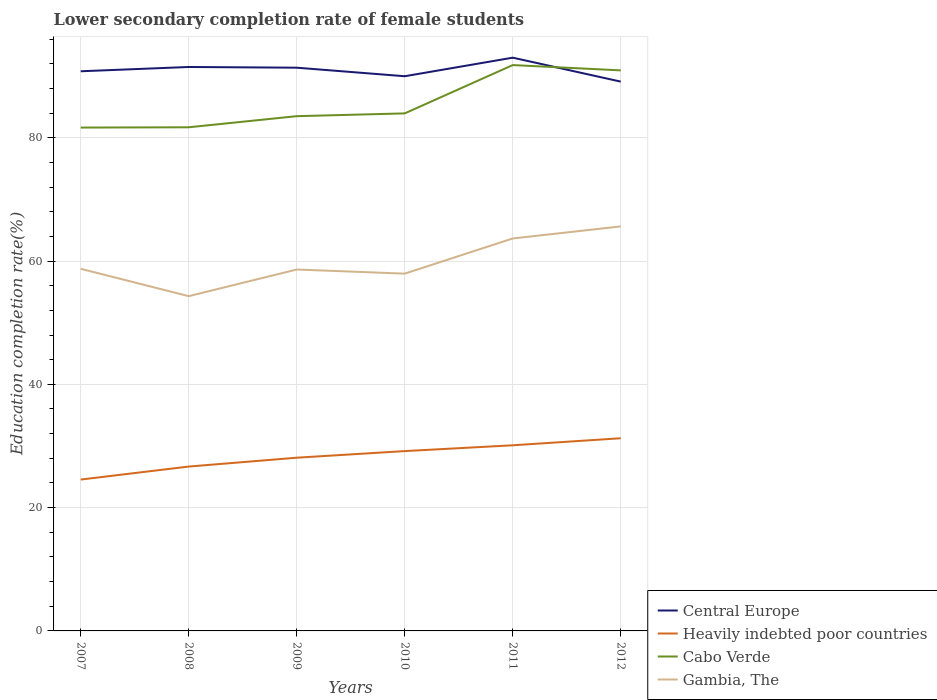How many different coloured lines are there?
Offer a terse response. 4. Across all years, what is the maximum lower secondary completion rate of female students in Gambia, The?
Make the answer very short. 54.3. In which year was the lower secondary completion rate of female students in Central Europe maximum?
Provide a succinct answer. 2012. What is the total lower secondary completion rate of female students in Cabo Verde in the graph?
Your answer should be very brief. 0.86. What is the difference between the highest and the second highest lower secondary completion rate of female students in Gambia, The?
Offer a very short reply. 11.31. What is the difference between the highest and the lowest lower secondary completion rate of female students in Cabo Verde?
Offer a terse response. 2. Are the values on the major ticks of Y-axis written in scientific E-notation?
Ensure brevity in your answer.  No. Does the graph contain any zero values?
Keep it short and to the point. No. How are the legend labels stacked?
Provide a short and direct response. Vertical. What is the title of the graph?
Offer a very short reply. Lower secondary completion rate of female students. What is the label or title of the Y-axis?
Make the answer very short. Education completion rate(%). What is the Education completion rate(%) in Central Europe in 2007?
Your answer should be very brief. 90.78. What is the Education completion rate(%) in Heavily indebted poor countries in 2007?
Keep it short and to the point. 24.55. What is the Education completion rate(%) in Cabo Verde in 2007?
Ensure brevity in your answer.  81.65. What is the Education completion rate(%) in Gambia, The in 2007?
Offer a very short reply. 58.74. What is the Education completion rate(%) of Central Europe in 2008?
Your answer should be compact. 91.48. What is the Education completion rate(%) of Heavily indebted poor countries in 2008?
Make the answer very short. 26.66. What is the Education completion rate(%) in Cabo Verde in 2008?
Offer a very short reply. 81.7. What is the Education completion rate(%) of Gambia, The in 2008?
Your response must be concise. 54.3. What is the Education completion rate(%) in Central Europe in 2009?
Keep it short and to the point. 91.36. What is the Education completion rate(%) in Heavily indebted poor countries in 2009?
Provide a succinct answer. 28.1. What is the Education completion rate(%) in Cabo Verde in 2009?
Provide a short and direct response. 83.5. What is the Education completion rate(%) of Gambia, The in 2009?
Your answer should be compact. 58.62. What is the Education completion rate(%) in Central Europe in 2010?
Offer a very short reply. 89.98. What is the Education completion rate(%) in Heavily indebted poor countries in 2010?
Ensure brevity in your answer.  29.17. What is the Education completion rate(%) in Cabo Verde in 2010?
Your answer should be very brief. 83.95. What is the Education completion rate(%) in Gambia, The in 2010?
Your answer should be very brief. 57.96. What is the Education completion rate(%) of Central Europe in 2011?
Keep it short and to the point. 92.99. What is the Education completion rate(%) in Heavily indebted poor countries in 2011?
Keep it short and to the point. 30.11. What is the Education completion rate(%) of Cabo Verde in 2011?
Your answer should be very brief. 91.79. What is the Education completion rate(%) of Gambia, The in 2011?
Make the answer very short. 63.66. What is the Education completion rate(%) in Central Europe in 2012?
Make the answer very short. 89.1. What is the Education completion rate(%) of Heavily indebted poor countries in 2012?
Ensure brevity in your answer.  31.25. What is the Education completion rate(%) in Cabo Verde in 2012?
Make the answer very short. 90.93. What is the Education completion rate(%) in Gambia, The in 2012?
Offer a very short reply. 65.62. Across all years, what is the maximum Education completion rate(%) in Central Europe?
Provide a short and direct response. 92.99. Across all years, what is the maximum Education completion rate(%) in Heavily indebted poor countries?
Keep it short and to the point. 31.25. Across all years, what is the maximum Education completion rate(%) of Cabo Verde?
Provide a succinct answer. 91.79. Across all years, what is the maximum Education completion rate(%) in Gambia, The?
Make the answer very short. 65.62. Across all years, what is the minimum Education completion rate(%) of Central Europe?
Provide a short and direct response. 89.1. Across all years, what is the minimum Education completion rate(%) of Heavily indebted poor countries?
Give a very brief answer. 24.55. Across all years, what is the minimum Education completion rate(%) of Cabo Verde?
Offer a very short reply. 81.65. Across all years, what is the minimum Education completion rate(%) in Gambia, The?
Your answer should be very brief. 54.3. What is the total Education completion rate(%) in Central Europe in the graph?
Provide a succinct answer. 545.69. What is the total Education completion rate(%) of Heavily indebted poor countries in the graph?
Keep it short and to the point. 169.85. What is the total Education completion rate(%) in Cabo Verde in the graph?
Provide a succinct answer. 513.51. What is the total Education completion rate(%) of Gambia, The in the graph?
Provide a succinct answer. 358.91. What is the difference between the Education completion rate(%) in Central Europe in 2007 and that in 2008?
Keep it short and to the point. -0.69. What is the difference between the Education completion rate(%) of Heavily indebted poor countries in 2007 and that in 2008?
Provide a succinct answer. -2.11. What is the difference between the Education completion rate(%) of Cabo Verde in 2007 and that in 2008?
Ensure brevity in your answer.  -0.05. What is the difference between the Education completion rate(%) in Gambia, The in 2007 and that in 2008?
Keep it short and to the point. 4.44. What is the difference between the Education completion rate(%) of Central Europe in 2007 and that in 2009?
Keep it short and to the point. -0.58. What is the difference between the Education completion rate(%) of Heavily indebted poor countries in 2007 and that in 2009?
Make the answer very short. -3.54. What is the difference between the Education completion rate(%) in Cabo Verde in 2007 and that in 2009?
Give a very brief answer. -1.85. What is the difference between the Education completion rate(%) in Gambia, The in 2007 and that in 2009?
Your answer should be compact. 0.12. What is the difference between the Education completion rate(%) in Central Europe in 2007 and that in 2010?
Keep it short and to the point. 0.81. What is the difference between the Education completion rate(%) in Heavily indebted poor countries in 2007 and that in 2010?
Offer a very short reply. -4.62. What is the difference between the Education completion rate(%) in Cabo Verde in 2007 and that in 2010?
Your response must be concise. -2.3. What is the difference between the Education completion rate(%) in Gambia, The in 2007 and that in 2010?
Your answer should be very brief. 0.79. What is the difference between the Education completion rate(%) of Central Europe in 2007 and that in 2011?
Your answer should be very brief. -2.21. What is the difference between the Education completion rate(%) in Heavily indebted poor countries in 2007 and that in 2011?
Your answer should be very brief. -5.56. What is the difference between the Education completion rate(%) in Cabo Verde in 2007 and that in 2011?
Keep it short and to the point. -10.14. What is the difference between the Education completion rate(%) in Gambia, The in 2007 and that in 2011?
Provide a succinct answer. -4.92. What is the difference between the Education completion rate(%) in Central Europe in 2007 and that in 2012?
Make the answer very short. 1.68. What is the difference between the Education completion rate(%) of Heavily indebted poor countries in 2007 and that in 2012?
Your answer should be very brief. -6.7. What is the difference between the Education completion rate(%) in Cabo Verde in 2007 and that in 2012?
Offer a very short reply. -9.28. What is the difference between the Education completion rate(%) of Gambia, The in 2007 and that in 2012?
Ensure brevity in your answer.  -6.87. What is the difference between the Education completion rate(%) of Central Europe in 2008 and that in 2009?
Ensure brevity in your answer.  0.11. What is the difference between the Education completion rate(%) of Heavily indebted poor countries in 2008 and that in 2009?
Provide a succinct answer. -1.44. What is the difference between the Education completion rate(%) of Cabo Verde in 2008 and that in 2009?
Your answer should be compact. -1.8. What is the difference between the Education completion rate(%) in Gambia, The in 2008 and that in 2009?
Your response must be concise. -4.32. What is the difference between the Education completion rate(%) in Central Europe in 2008 and that in 2010?
Provide a succinct answer. 1.5. What is the difference between the Education completion rate(%) in Heavily indebted poor countries in 2008 and that in 2010?
Your answer should be compact. -2.51. What is the difference between the Education completion rate(%) in Cabo Verde in 2008 and that in 2010?
Provide a short and direct response. -2.25. What is the difference between the Education completion rate(%) of Gambia, The in 2008 and that in 2010?
Your response must be concise. -3.65. What is the difference between the Education completion rate(%) in Central Europe in 2008 and that in 2011?
Keep it short and to the point. -1.51. What is the difference between the Education completion rate(%) in Heavily indebted poor countries in 2008 and that in 2011?
Make the answer very short. -3.45. What is the difference between the Education completion rate(%) of Cabo Verde in 2008 and that in 2011?
Offer a terse response. -10.09. What is the difference between the Education completion rate(%) of Gambia, The in 2008 and that in 2011?
Offer a very short reply. -9.36. What is the difference between the Education completion rate(%) in Central Europe in 2008 and that in 2012?
Ensure brevity in your answer.  2.37. What is the difference between the Education completion rate(%) of Heavily indebted poor countries in 2008 and that in 2012?
Make the answer very short. -4.59. What is the difference between the Education completion rate(%) of Cabo Verde in 2008 and that in 2012?
Your answer should be very brief. -9.23. What is the difference between the Education completion rate(%) in Gambia, The in 2008 and that in 2012?
Offer a very short reply. -11.31. What is the difference between the Education completion rate(%) in Central Europe in 2009 and that in 2010?
Your response must be concise. 1.39. What is the difference between the Education completion rate(%) in Heavily indebted poor countries in 2009 and that in 2010?
Your answer should be very brief. -1.07. What is the difference between the Education completion rate(%) of Cabo Verde in 2009 and that in 2010?
Make the answer very short. -0.45. What is the difference between the Education completion rate(%) of Gambia, The in 2009 and that in 2010?
Your answer should be compact. 0.67. What is the difference between the Education completion rate(%) in Central Europe in 2009 and that in 2011?
Offer a very short reply. -1.63. What is the difference between the Education completion rate(%) in Heavily indebted poor countries in 2009 and that in 2011?
Ensure brevity in your answer.  -2.02. What is the difference between the Education completion rate(%) of Cabo Verde in 2009 and that in 2011?
Your response must be concise. -8.29. What is the difference between the Education completion rate(%) of Gambia, The in 2009 and that in 2011?
Your answer should be compact. -5.04. What is the difference between the Education completion rate(%) in Central Europe in 2009 and that in 2012?
Make the answer very short. 2.26. What is the difference between the Education completion rate(%) of Heavily indebted poor countries in 2009 and that in 2012?
Provide a succinct answer. -3.16. What is the difference between the Education completion rate(%) of Cabo Verde in 2009 and that in 2012?
Keep it short and to the point. -7.43. What is the difference between the Education completion rate(%) of Gambia, The in 2009 and that in 2012?
Make the answer very short. -6.99. What is the difference between the Education completion rate(%) in Central Europe in 2010 and that in 2011?
Offer a terse response. -3.01. What is the difference between the Education completion rate(%) of Heavily indebted poor countries in 2010 and that in 2011?
Keep it short and to the point. -0.94. What is the difference between the Education completion rate(%) in Cabo Verde in 2010 and that in 2011?
Offer a terse response. -7.84. What is the difference between the Education completion rate(%) of Gambia, The in 2010 and that in 2011?
Offer a very short reply. -5.71. What is the difference between the Education completion rate(%) of Central Europe in 2010 and that in 2012?
Make the answer very short. 0.87. What is the difference between the Education completion rate(%) of Heavily indebted poor countries in 2010 and that in 2012?
Make the answer very short. -2.08. What is the difference between the Education completion rate(%) in Cabo Verde in 2010 and that in 2012?
Keep it short and to the point. -6.98. What is the difference between the Education completion rate(%) in Gambia, The in 2010 and that in 2012?
Provide a short and direct response. -7.66. What is the difference between the Education completion rate(%) in Central Europe in 2011 and that in 2012?
Offer a terse response. 3.88. What is the difference between the Education completion rate(%) of Heavily indebted poor countries in 2011 and that in 2012?
Keep it short and to the point. -1.14. What is the difference between the Education completion rate(%) of Cabo Verde in 2011 and that in 2012?
Ensure brevity in your answer.  0.86. What is the difference between the Education completion rate(%) in Gambia, The in 2011 and that in 2012?
Your response must be concise. -1.95. What is the difference between the Education completion rate(%) in Central Europe in 2007 and the Education completion rate(%) in Heavily indebted poor countries in 2008?
Offer a very short reply. 64.12. What is the difference between the Education completion rate(%) of Central Europe in 2007 and the Education completion rate(%) of Cabo Verde in 2008?
Provide a short and direct response. 9.08. What is the difference between the Education completion rate(%) of Central Europe in 2007 and the Education completion rate(%) of Gambia, The in 2008?
Provide a short and direct response. 36.48. What is the difference between the Education completion rate(%) of Heavily indebted poor countries in 2007 and the Education completion rate(%) of Cabo Verde in 2008?
Your answer should be very brief. -57.14. What is the difference between the Education completion rate(%) of Heavily indebted poor countries in 2007 and the Education completion rate(%) of Gambia, The in 2008?
Provide a succinct answer. -29.75. What is the difference between the Education completion rate(%) in Cabo Verde in 2007 and the Education completion rate(%) in Gambia, The in 2008?
Ensure brevity in your answer.  27.35. What is the difference between the Education completion rate(%) of Central Europe in 2007 and the Education completion rate(%) of Heavily indebted poor countries in 2009?
Offer a terse response. 62.68. What is the difference between the Education completion rate(%) in Central Europe in 2007 and the Education completion rate(%) in Cabo Verde in 2009?
Give a very brief answer. 7.28. What is the difference between the Education completion rate(%) of Central Europe in 2007 and the Education completion rate(%) of Gambia, The in 2009?
Provide a short and direct response. 32.16. What is the difference between the Education completion rate(%) in Heavily indebted poor countries in 2007 and the Education completion rate(%) in Cabo Verde in 2009?
Provide a succinct answer. -58.94. What is the difference between the Education completion rate(%) in Heavily indebted poor countries in 2007 and the Education completion rate(%) in Gambia, The in 2009?
Provide a short and direct response. -34.07. What is the difference between the Education completion rate(%) of Cabo Verde in 2007 and the Education completion rate(%) of Gambia, The in 2009?
Provide a short and direct response. 23.02. What is the difference between the Education completion rate(%) of Central Europe in 2007 and the Education completion rate(%) of Heavily indebted poor countries in 2010?
Make the answer very short. 61.61. What is the difference between the Education completion rate(%) of Central Europe in 2007 and the Education completion rate(%) of Cabo Verde in 2010?
Offer a terse response. 6.83. What is the difference between the Education completion rate(%) in Central Europe in 2007 and the Education completion rate(%) in Gambia, The in 2010?
Offer a very short reply. 32.83. What is the difference between the Education completion rate(%) of Heavily indebted poor countries in 2007 and the Education completion rate(%) of Cabo Verde in 2010?
Your response must be concise. -59.4. What is the difference between the Education completion rate(%) in Heavily indebted poor countries in 2007 and the Education completion rate(%) in Gambia, The in 2010?
Give a very brief answer. -33.4. What is the difference between the Education completion rate(%) in Cabo Verde in 2007 and the Education completion rate(%) in Gambia, The in 2010?
Provide a succinct answer. 23.69. What is the difference between the Education completion rate(%) in Central Europe in 2007 and the Education completion rate(%) in Heavily indebted poor countries in 2011?
Ensure brevity in your answer.  60.67. What is the difference between the Education completion rate(%) in Central Europe in 2007 and the Education completion rate(%) in Cabo Verde in 2011?
Make the answer very short. -1. What is the difference between the Education completion rate(%) of Central Europe in 2007 and the Education completion rate(%) of Gambia, The in 2011?
Keep it short and to the point. 27.12. What is the difference between the Education completion rate(%) in Heavily indebted poor countries in 2007 and the Education completion rate(%) in Cabo Verde in 2011?
Your answer should be very brief. -67.23. What is the difference between the Education completion rate(%) of Heavily indebted poor countries in 2007 and the Education completion rate(%) of Gambia, The in 2011?
Offer a terse response. -39.11. What is the difference between the Education completion rate(%) of Cabo Verde in 2007 and the Education completion rate(%) of Gambia, The in 2011?
Your response must be concise. 17.99. What is the difference between the Education completion rate(%) of Central Europe in 2007 and the Education completion rate(%) of Heavily indebted poor countries in 2012?
Your answer should be compact. 59.53. What is the difference between the Education completion rate(%) in Central Europe in 2007 and the Education completion rate(%) in Cabo Verde in 2012?
Keep it short and to the point. -0.15. What is the difference between the Education completion rate(%) in Central Europe in 2007 and the Education completion rate(%) in Gambia, The in 2012?
Offer a very short reply. 25.16. What is the difference between the Education completion rate(%) in Heavily indebted poor countries in 2007 and the Education completion rate(%) in Cabo Verde in 2012?
Keep it short and to the point. -66.37. What is the difference between the Education completion rate(%) of Heavily indebted poor countries in 2007 and the Education completion rate(%) of Gambia, The in 2012?
Ensure brevity in your answer.  -41.06. What is the difference between the Education completion rate(%) of Cabo Verde in 2007 and the Education completion rate(%) of Gambia, The in 2012?
Your answer should be very brief. 16.03. What is the difference between the Education completion rate(%) in Central Europe in 2008 and the Education completion rate(%) in Heavily indebted poor countries in 2009?
Offer a very short reply. 63.38. What is the difference between the Education completion rate(%) of Central Europe in 2008 and the Education completion rate(%) of Cabo Verde in 2009?
Provide a short and direct response. 7.98. What is the difference between the Education completion rate(%) of Central Europe in 2008 and the Education completion rate(%) of Gambia, The in 2009?
Make the answer very short. 32.85. What is the difference between the Education completion rate(%) of Heavily indebted poor countries in 2008 and the Education completion rate(%) of Cabo Verde in 2009?
Your response must be concise. -56.84. What is the difference between the Education completion rate(%) in Heavily indebted poor countries in 2008 and the Education completion rate(%) in Gambia, The in 2009?
Your answer should be very brief. -31.96. What is the difference between the Education completion rate(%) in Cabo Verde in 2008 and the Education completion rate(%) in Gambia, The in 2009?
Your response must be concise. 23.07. What is the difference between the Education completion rate(%) of Central Europe in 2008 and the Education completion rate(%) of Heavily indebted poor countries in 2010?
Offer a terse response. 62.31. What is the difference between the Education completion rate(%) of Central Europe in 2008 and the Education completion rate(%) of Cabo Verde in 2010?
Make the answer very short. 7.53. What is the difference between the Education completion rate(%) of Central Europe in 2008 and the Education completion rate(%) of Gambia, The in 2010?
Your answer should be very brief. 33.52. What is the difference between the Education completion rate(%) in Heavily indebted poor countries in 2008 and the Education completion rate(%) in Cabo Verde in 2010?
Give a very brief answer. -57.29. What is the difference between the Education completion rate(%) in Heavily indebted poor countries in 2008 and the Education completion rate(%) in Gambia, The in 2010?
Offer a terse response. -31.29. What is the difference between the Education completion rate(%) of Cabo Verde in 2008 and the Education completion rate(%) of Gambia, The in 2010?
Keep it short and to the point. 23.74. What is the difference between the Education completion rate(%) of Central Europe in 2008 and the Education completion rate(%) of Heavily indebted poor countries in 2011?
Keep it short and to the point. 61.36. What is the difference between the Education completion rate(%) of Central Europe in 2008 and the Education completion rate(%) of Cabo Verde in 2011?
Offer a terse response. -0.31. What is the difference between the Education completion rate(%) of Central Europe in 2008 and the Education completion rate(%) of Gambia, The in 2011?
Offer a terse response. 27.81. What is the difference between the Education completion rate(%) in Heavily indebted poor countries in 2008 and the Education completion rate(%) in Cabo Verde in 2011?
Ensure brevity in your answer.  -65.12. What is the difference between the Education completion rate(%) of Heavily indebted poor countries in 2008 and the Education completion rate(%) of Gambia, The in 2011?
Provide a short and direct response. -37. What is the difference between the Education completion rate(%) of Cabo Verde in 2008 and the Education completion rate(%) of Gambia, The in 2011?
Provide a short and direct response. 18.04. What is the difference between the Education completion rate(%) of Central Europe in 2008 and the Education completion rate(%) of Heavily indebted poor countries in 2012?
Give a very brief answer. 60.22. What is the difference between the Education completion rate(%) of Central Europe in 2008 and the Education completion rate(%) of Cabo Verde in 2012?
Make the answer very short. 0.55. What is the difference between the Education completion rate(%) of Central Europe in 2008 and the Education completion rate(%) of Gambia, The in 2012?
Offer a very short reply. 25.86. What is the difference between the Education completion rate(%) of Heavily indebted poor countries in 2008 and the Education completion rate(%) of Cabo Verde in 2012?
Ensure brevity in your answer.  -64.27. What is the difference between the Education completion rate(%) of Heavily indebted poor countries in 2008 and the Education completion rate(%) of Gambia, The in 2012?
Your answer should be compact. -38.95. What is the difference between the Education completion rate(%) in Cabo Verde in 2008 and the Education completion rate(%) in Gambia, The in 2012?
Provide a succinct answer. 16.08. What is the difference between the Education completion rate(%) in Central Europe in 2009 and the Education completion rate(%) in Heavily indebted poor countries in 2010?
Offer a very short reply. 62.19. What is the difference between the Education completion rate(%) of Central Europe in 2009 and the Education completion rate(%) of Cabo Verde in 2010?
Your answer should be compact. 7.41. What is the difference between the Education completion rate(%) in Central Europe in 2009 and the Education completion rate(%) in Gambia, The in 2010?
Your answer should be compact. 33.41. What is the difference between the Education completion rate(%) in Heavily indebted poor countries in 2009 and the Education completion rate(%) in Cabo Verde in 2010?
Your answer should be very brief. -55.85. What is the difference between the Education completion rate(%) in Heavily indebted poor countries in 2009 and the Education completion rate(%) in Gambia, The in 2010?
Offer a terse response. -29.86. What is the difference between the Education completion rate(%) in Cabo Verde in 2009 and the Education completion rate(%) in Gambia, The in 2010?
Keep it short and to the point. 25.54. What is the difference between the Education completion rate(%) in Central Europe in 2009 and the Education completion rate(%) in Heavily indebted poor countries in 2011?
Provide a succinct answer. 61.25. What is the difference between the Education completion rate(%) in Central Europe in 2009 and the Education completion rate(%) in Cabo Verde in 2011?
Ensure brevity in your answer.  -0.42. What is the difference between the Education completion rate(%) of Central Europe in 2009 and the Education completion rate(%) of Gambia, The in 2011?
Your response must be concise. 27.7. What is the difference between the Education completion rate(%) of Heavily indebted poor countries in 2009 and the Education completion rate(%) of Cabo Verde in 2011?
Provide a succinct answer. -63.69. What is the difference between the Education completion rate(%) in Heavily indebted poor countries in 2009 and the Education completion rate(%) in Gambia, The in 2011?
Your answer should be very brief. -35.56. What is the difference between the Education completion rate(%) of Cabo Verde in 2009 and the Education completion rate(%) of Gambia, The in 2011?
Give a very brief answer. 19.84. What is the difference between the Education completion rate(%) of Central Europe in 2009 and the Education completion rate(%) of Heavily indebted poor countries in 2012?
Ensure brevity in your answer.  60.11. What is the difference between the Education completion rate(%) in Central Europe in 2009 and the Education completion rate(%) in Cabo Verde in 2012?
Give a very brief answer. 0.43. What is the difference between the Education completion rate(%) in Central Europe in 2009 and the Education completion rate(%) in Gambia, The in 2012?
Provide a short and direct response. 25.75. What is the difference between the Education completion rate(%) of Heavily indebted poor countries in 2009 and the Education completion rate(%) of Cabo Verde in 2012?
Provide a short and direct response. -62.83. What is the difference between the Education completion rate(%) of Heavily indebted poor countries in 2009 and the Education completion rate(%) of Gambia, The in 2012?
Ensure brevity in your answer.  -37.52. What is the difference between the Education completion rate(%) in Cabo Verde in 2009 and the Education completion rate(%) in Gambia, The in 2012?
Make the answer very short. 17.88. What is the difference between the Education completion rate(%) of Central Europe in 2010 and the Education completion rate(%) of Heavily indebted poor countries in 2011?
Provide a succinct answer. 59.86. What is the difference between the Education completion rate(%) in Central Europe in 2010 and the Education completion rate(%) in Cabo Verde in 2011?
Your response must be concise. -1.81. What is the difference between the Education completion rate(%) in Central Europe in 2010 and the Education completion rate(%) in Gambia, The in 2011?
Your answer should be compact. 26.31. What is the difference between the Education completion rate(%) in Heavily indebted poor countries in 2010 and the Education completion rate(%) in Cabo Verde in 2011?
Offer a terse response. -62.62. What is the difference between the Education completion rate(%) of Heavily indebted poor countries in 2010 and the Education completion rate(%) of Gambia, The in 2011?
Make the answer very short. -34.49. What is the difference between the Education completion rate(%) of Cabo Verde in 2010 and the Education completion rate(%) of Gambia, The in 2011?
Provide a succinct answer. 20.29. What is the difference between the Education completion rate(%) of Central Europe in 2010 and the Education completion rate(%) of Heavily indebted poor countries in 2012?
Keep it short and to the point. 58.72. What is the difference between the Education completion rate(%) of Central Europe in 2010 and the Education completion rate(%) of Cabo Verde in 2012?
Your answer should be very brief. -0.95. What is the difference between the Education completion rate(%) of Central Europe in 2010 and the Education completion rate(%) of Gambia, The in 2012?
Provide a short and direct response. 24.36. What is the difference between the Education completion rate(%) of Heavily indebted poor countries in 2010 and the Education completion rate(%) of Cabo Verde in 2012?
Ensure brevity in your answer.  -61.76. What is the difference between the Education completion rate(%) in Heavily indebted poor countries in 2010 and the Education completion rate(%) in Gambia, The in 2012?
Provide a short and direct response. -36.45. What is the difference between the Education completion rate(%) of Cabo Verde in 2010 and the Education completion rate(%) of Gambia, The in 2012?
Offer a very short reply. 18.33. What is the difference between the Education completion rate(%) of Central Europe in 2011 and the Education completion rate(%) of Heavily indebted poor countries in 2012?
Keep it short and to the point. 61.73. What is the difference between the Education completion rate(%) in Central Europe in 2011 and the Education completion rate(%) in Cabo Verde in 2012?
Provide a succinct answer. 2.06. What is the difference between the Education completion rate(%) in Central Europe in 2011 and the Education completion rate(%) in Gambia, The in 2012?
Keep it short and to the point. 27.37. What is the difference between the Education completion rate(%) in Heavily indebted poor countries in 2011 and the Education completion rate(%) in Cabo Verde in 2012?
Your answer should be compact. -60.81. What is the difference between the Education completion rate(%) in Heavily indebted poor countries in 2011 and the Education completion rate(%) in Gambia, The in 2012?
Give a very brief answer. -35.5. What is the difference between the Education completion rate(%) in Cabo Verde in 2011 and the Education completion rate(%) in Gambia, The in 2012?
Offer a very short reply. 26.17. What is the average Education completion rate(%) of Central Europe per year?
Your answer should be compact. 90.95. What is the average Education completion rate(%) of Heavily indebted poor countries per year?
Ensure brevity in your answer.  28.31. What is the average Education completion rate(%) in Cabo Verde per year?
Provide a short and direct response. 85.58. What is the average Education completion rate(%) of Gambia, The per year?
Your answer should be very brief. 59.82. In the year 2007, what is the difference between the Education completion rate(%) in Central Europe and Education completion rate(%) in Heavily indebted poor countries?
Make the answer very short. 66.23. In the year 2007, what is the difference between the Education completion rate(%) in Central Europe and Education completion rate(%) in Cabo Verde?
Provide a succinct answer. 9.13. In the year 2007, what is the difference between the Education completion rate(%) in Central Europe and Education completion rate(%) in Gambia, The?
Offer a very short reply. 32.04. In the year 2007, what is the difference between the Education completion rate(%) of Heavily indebted poor countries and Education completion rate(%) of Cabo Verde?
Your response must be concise. -57.1. In the year 2007, what is the difference between the Education completion rate(%) in Heavily indebted poor countries and Education completion rate(%) in Gambia, The?
Provide a short and direct response. -34.19. In the year 2007, what is the difference between the Education completion rate(%) of Cabo Verde and Education completion rate(%) of Gambia, The?
Keep it short and to the point. 22.91. In the year 2008, what is the difference between the Education completion rate(%) in Central Europe and Education completion rate(%) in Heavily indebted poor countries?
Ensure brevity in your answer.  64.81. In the year 2008, what is the difference between the Education completion rate(%) of Central Europe and Education completion rate(%) of Cabo Verde?
Make the answer very short. 9.78. In the year 2008, what is the difference between the Education completion rate(%) in Central Europe and Education completion rate(%) in Gambia, The?
Give a very brief answer. 37.17. In the year 2008, what is the difference between the Education completion rate(%) of Heavily indebted poor countries and Education completion rate(%) of Cabo Verde?
Offer a very short reply. -55.03. In the year 2008, what is the difference between the Education completion rate(%) in Heavily indebted poor countries and Education completion rate(%) in Gambia, The?
Keep it short and to the point. -27.64. In the year 2008, what is the difference between the Education completion rate(%) of Cabo Verde and Education completion rate(%) of Gambia, The?
Make the answer very short. 27.39. In the year 2009, what is the difference between the Education completion rate(%) of Central Europe and Education completion rate(%) of Heavily indebted poor countries?
Provide a short and direct response. 63.26. In the year 2009, what is the difference between the Education completion rate(%) in Central Europe and Education completion rate(%) in Cabo Verde?
Keep it short and to the point. 7.86. In the year 2009, what is the difference between the Education completion rate(%) of Central Europe and Education completion rate(%) of Gambia, The?
Give a very brief answer. 32.74. In the year 2009, what is the difference between the Education completion rate(%) of Heavily indebted poor countries and Education completion rate(%) of Cabo Verde?
Offer a terse response. -55.4. In the year 2009, what is the difference between the Education completion rate(%) of Heavily indebted poor countries and Education completion rate(%) of Gambia, The?
Give a very brief answer. -30.53. In the year 2009, what is the difference between the Education completion rate(%) of Cabo Verde and Education completion rate(%) of Gambia, The?
Offer a very short reply. 24.87. In the year 2010, what is the difference between the Education completion rate(%) of Central Europe and Education completion rate(%) of Heavily indebted poor countries?
Make the answer very short. 60.81. In the year 2010, what is the difference between the Education completion rate(%) in Central Europe and Education completion rate(%) in Cabo Verde?
Keep it short and to the point. 6.03. In the year 2010, what is the difference between the Education completion rate(%) in Central Europe and Education completion rate(%) in Gambia, The?
Provide a succinct answer. 32.02. In the year 2010, what is the difference between the Education completion rate(%) in Heavily indebted poor countries and Education completion rate(%) in Cabo Verde?
Your answer should be compact. -54.78. In the year 2010, what is the difference between the Education completion rate(%) in Heavily indebted poor countries and Education completion rate(%) in Gambia, The?
Your response must be concise. -28.79. In the year 2010, what is the difference between the Education completion rate(%) of Cabo Verde and Education completion rate(%) of Gambia, The?
Give a very brief answer. 25.99. In the year 2011, what is the difference between the Education completion rate(%) in Central Europe and Education completion rate(%) in Heavily indebted poor countries?
Your answer should be compact. 62.88. In the year 2011, what is the difference between the Education completion rate(%) of Central Europe and Education completion rate(%) of Cabo Verde?
Ensure brevity in your answer.  1.2. In the year 2011, what is the difference between the Education completion rate(%) in Central Europe and Education completion rate(%) in Gambia, The?
Your response must be concise. 29.33. In the year 2011, what is the difference between the Education completion rate(%) of Heavily indebted poor countries and Education completion rate(%) of Cabo Verde?
Your response must be concise. -61.67. In the year 2011, what is the difference between the Education completion rate(%) of Heavily indebted poor countries and Education completion rate(%) of Gambia, The?
Your answer should be very brief. -33.55. In the year 2011, what is the difference between the Education completion rate(%) in Cabo Verde and Education completion rate(%) in Gambia, The?
Provide a succinct answer. 28.12. In the year 2012, what is the difference between the Education completion rate(%) of Central Europe and Education completion rate(%) of Heavily indebted poor countries?
Your answer should be compact. 57.85. In the year 2012, what is the difference between the Education completion rate(%) in Central Europe and Education completion rate(%) in Cabo Verde?
Give a very brief answer. -1.82. In the year 2012, what is the difference between the Education completion rate(%) in Central Europe and Education completion rate(%) in Gambia, The?
Offer a terse response. 23.49. In the year 2012, what is the difference between the Education completion rate(%) of Heavily indebted poor countries and Education completion rate(%) of Cabo Verde?
Your answer should be compact. -59.67. In the year 2012, what is the difference between the Education completion rate(%) of Heavily indebted poor countries and Education completion rate(%) of Gambia, The?
Your response must be concise. -34.36. In the year 2012, what is the difference between the Education completion rate(%) in Cabo Verde and Education completion rate(%) in Gambia, The?
Ensure brevity in your answer.  25.31. What is the ratio of the Education completion rate(%) of Central Europe in 2007 to that in 2008?
Ensure brevity in your answer.  0.99. What is the ratio of the Education completion rate(%) in Heavily indebted poor countries in 2007 to that in 2008?
Offer a terse response. 0.92. What is the ratio of the Education completion rate(%) in Gambia, The in 2007 to that in 2008?
Offer a very short reply. 1.08. What is the ratio of the Education completion rate(%) of Central Europe in 2007 to that in 2009?
Offer a very short reply. 0.99. What is the ratio of the Education completion rate(%) in Heavily indebted poor countries in 2007 to that in 2009?
Provide a succinct answer. 0.87. What is the ratio of the Education completion rate(%) of Cabo Verde in 2007 to that in 2009?
Make the answer very short. 0.98. What is the ratio of the Education completion rate(%) of Gambia, The in 2007 to that in 2009?
Give a very brief answer. 1. What is the ratio of the Education completion rate(%) of Central Europe in 2007 to that in 2010?
Offer a very short reply. 1.01. What is the ratio of the Education completion rate(%) in Heavily indebted poor countries in 2007 to that in 2010?
Your answer should be very brief. 0.84. What is the ratio of the Education completion rate(%) of Cabo Verde in 2007 to that in 2010?
Provide a succinct answer. 0.97. What is the ratio of the Education completion rate(%) of Gambia, The in 2007 to that in 2010?
Provide a succinct answer. 1.01. What is the ratio of the Education completion rate(%) of Central Europe in 2007 to that in 2011?
Provide a succinct answer. 0.98. What is the ratio of the Education completion rate(%) in Heavily indebted poor countries in 2007 to that in 2011?
Keep it short and to the point. 0.82. What is the ratio of the Education completion rate(%) in Cabo Verde in 2007 to that in 2011?
Your answer should be very brief. 0.89. What is the ratio of the Education completion rate(%) of Gambia, The in 2007 to that in 2011?
Your answer should be very brief. 0.92. What is the ratio of the Education completion rate(%) of Central Europe in 2007 to that in 2012?
Your answer should be compact. 1.02. What is the ratio of the Education completion rate(%) in Heavily indebted poor countries in 2007 to that in 2012?
Provide a short and direct response. 0.79. What is the ratio of the Education completion rate(%) of Cabo Verde in 2007 to that in 2012?
Make the answer very short. 0.9. What is the ratio of the Education completion rate(%) of Gambia, The in 2007 to that in 2012?
Your answer should be very brief. 0.9. What is the ratio of the Education completion rate(%) in Heavily indebted poor countries in 2008 to that in 2009?
Your response must be concise. 0.95. What is the ratio of the Education completion rate(%) of Cabo Verde in 2008 to that in 2009?
Keep it short and to the point. 0.98. What is the ratio of the Education completion rate(%) of Gambia, The in 2008 to that in 2009?
Provide a short and direct response. 0.93. What is the ratio of the Education completion rate(%) in Central Europe in 2008 to that in 2010?
Your response must be concise. 1.02. What is the ratio of the Education completion rate(%) in Heavily indebted poor countries in 2008 to that in 2010?
Make the answer very short. 0.91. What is the ratio of the Education completion rate(%) in Cabo Verde in 2008 to that in 2010?
Give a very brief answer. 0.97. What is the ratio of the Education completion rate(%) of Gambia, The in 2008 to that in 2010?
Provide a short and direct response. 0.94. What is the ratio of the Education completion rate(%) of Central Europe in 2008 to that in 2011?
Your answer should be very brief. 0.98. What is the ratio of the Education completion rate(%) of Heavily indebted poor countries in 2008 to that in 2011?
Keep it short and to the point. 0.89. What is the ratio of the Education completion rate(%) in Cabo Verde in 2008 to that in 2011?
Make the answer very short. 0.89. What is the ratio of the Education completion rate(%) of Gambia, The in 2008 to that in 2011?
Your response must be concise. 0.85. What is the ratio of the Education completion rate(%) in Central Europe in 2008 to that in 2012?
Give a very brief answer. 1.03. What is the ratio of the Education completion rate(%) in Heavily indebted poor countries in 2008 to that in 2012?
Provide a short and direct response. 0.85. What is the ratio of the Education completion rate(%) in Cabo Verde in 2008 to that in 2012?
Provide a short and direct response. 0.9. What is the ratio of the Education completion rate(%) in Gambia, The in 2008 to that in 2012?
Provide a short and direct response. 0.83. What is the ratio of the Education completion rate(%) of Central Europe in 2009 to that in 2010?
Keep it short and to the point. 1.02. What is the ratio of the Education completion rate(%) of Heavily indebted poor countries in 2009 to that in 2010?
Your answer should be very brief. 0.96. What is the ratio of the Education completion rate(%) of Gambia, The in 2009 to that in 2010?
Offer a terse response. 1.01. What is the ratio of the Education completion rate(%) in Central Europe in 2009 to that in 2011?
Your response must be concise. 0.98. What is the ratio of the Education completion rate(%) in Heavily indebted poor countries in 2009 to that in 2011?
Offer a terse response. 0.93. What is the ratio of the Education completion rate(%) of Cabo Verde in 2009 to that in 2011?
Provide a succinct answer. 0.91. What is the ratio of the Education completion rate(%) in Gambia, The in 2009 to that in 2011?
Offer a terse response. 0.92. What is the ratio of the Education completion rate(%) of Central Europe in 2009 to that in 2012?
Provide a succinct answer. 1.03. What is the ratio of the Education completion rate(%) in Heavily indebted poor countries in 2009 to that in 2012?
Make the answer very short. 0.9. What is the ratio of the Education completion rate(%) in Cabo Verde in 2009 to that in 2012?
Your response must be concise. 0.92. What is the ratio of the Education completion rate(%) in Gambia, The in 2009 to that in 2012?
Provide a short and direct response. 0.89. What is the ratio of the Education completion rate(%) of Central Europe in 2010 to that in 2011?
Provide a short and direct response. 0.97. What is the ratio of the Education completion rate(%) of Heavily indebted poor countries in 2010 to that in 2011?
Make the answer very short. 0.97. What is the ratio of the Education completion rate(%) in Cabo Verde in 2010 to that in 2011?
Keep it short and to the point. 0.91. What is the ratio of the Education completion rate(%) in Gambia, The in 2010 to that in 2011?
Offer a terse response. 0.91. What is the ratio of the Education completion rate(%) of Central Europe in 2010 to that in 2012?
Offer a terse response. 1.01. What is the ratio of the Education completion rate(%) in Cabo Verde in 2010 to that in 2012?
Provide a succinct answer. 0.92. What is the ratio of the Education completion rate(%) of Gambia, The in 2010 to that in 2012?
Keep it short and to the point. 0.88. What is the ratio of the Education completion rate(%) of Central Europe in 2011 to that in 2012?
Make the answer very short. 1.04. What is the ratio of the Education completion rate(%) in Heavily indebted poor countries in 2011 to that in 2012?
Offer a terse response. 0.96. What is the ratio of the Education completion rate(%) in Cabo Verde in 2011 to that in 2012?
Keep it short and to the point. 1.01. What is the ratio of the Education completion rate(%) of Gambia, The in 2011 to that in 2012?
Your answer should be very brief. 0.97. What is the difference between the highest and the second highest Education completion rate(%) in Central Europe?
Offer a very short reply. 1.51. What is the difference between the highest and the second highest Education completion rate(%) of Heavily indebted poor countries?
Your response must be concise. 1.14. What is the difference between the highest and the second highest Education completion rate(%) in Cabo Verde?
Your answer should be compact. 0.86. What is the difference between the highest and the second highest Education completion rate(%) of Gambia, The?
Your response must be concise. 1.95. What is the difference between the highest and the lowest Education completion rate(%) of Central Europe?
Provide a succinct answer. 3.88. What is the difference between the highest and the lowest Education completion rate(%) of Heavily indebted poor countries?
Your answer should be very brief. 6.7. What is the difference between the highest and the lowest Education completion rate(%) in Cabo Verde?
Provide a succinct answer. 10.14. What is the difference between the highest and the lowest Education completion rate(%) in Gambia, The?
Provide a short and direct response. 11.31. 